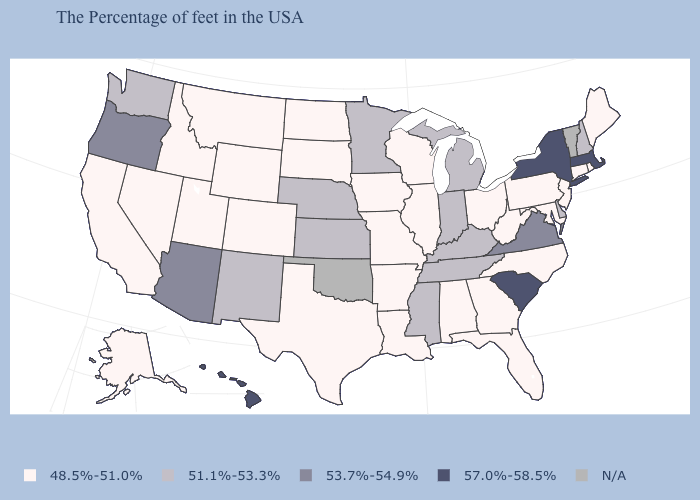Name the states that have a value in the range 48.5%-51.0%?
Quick response, please. Maine, Rhode Island, Connecticut, New Jersey, Maryland, Pennsylvania, North Carolina, West Virginia, Ohio, Florida, Georgia, Alabama, Wisconsin, Illinois, Louisiana, Missouri, Arkansas, Iowa, Texas, South Dakota, North Dakota, Wyoming, Colorado, Utah, Montana, Idaho, Nevada, California, Alaska. Name the states that have a value in the range 48.5%-51.0%?
Concise answer only. Maine, Rhode Island, Connecticut, New Jersey, Maryland, Pennsylvania, North Carolina, West Virginia, Ohio, Florida, Georgia, Alabama, Wisconsin, Illinois, Louisiana, Missouri, Arkansas, Iowa, Texas, South Dakota, North Dakota, Wyoming, Colorado, Utah, Montana, Idaho, Nevada, California, Alaska. Is the legend a continuous bar?
Write a very short answer. No. Name the states that have a value in the range 51.1%-53.3%?
Concise answer only. New Hampshire, Delaware, Michigan, Kentucky, Indiana, Tennessee, Mississippi, Minnesota, Kansas, Nebraska, New Mexico, Washington. Which states have the lowest value in the Northeast?
Quick response, please. Maine, Rhode Island, Connecticut, New Jersey, Pennsylvania. Does the first symbol in the legend represent the smallest category?
Write a very short answer. Yes. Which states have the lowest value in the USA?
Be succinct. Maine, Rhode Island, Connecticut, New Jersey, Maryland, Pennsylvania, North Carolina, West Virginia, Ohio, Florida, Georgia, Alabama, Wisconsin, Illinois, Louisiana, Missouri, Arkansas, Iowa, Texas, South Dakota, North Dakota, Wyoming, Colorado, Utah, Montana, Idaho, Nevada, California, Alaska. Name the states that have a value in the range 53.7%-54.9%?
Quick response, please. Virginia, Arizona, Oregon. Among the states that border Colorado , which have the highest value?
Concise answer only. Arizona. Among the states that border New Jersey , which have the highest value?
Answer briefly. New York. What is the highest value in states that border Kentucky?
Short answer required. 53.7%-54.9%. How many symbols are there in the legend?
Concise answer only. 5. What is the highest value in states that border California?
Give a very brief answer. 53.7%-54.9%. Which states hav the highest value in the West?
Be succinct. Hawaii. 